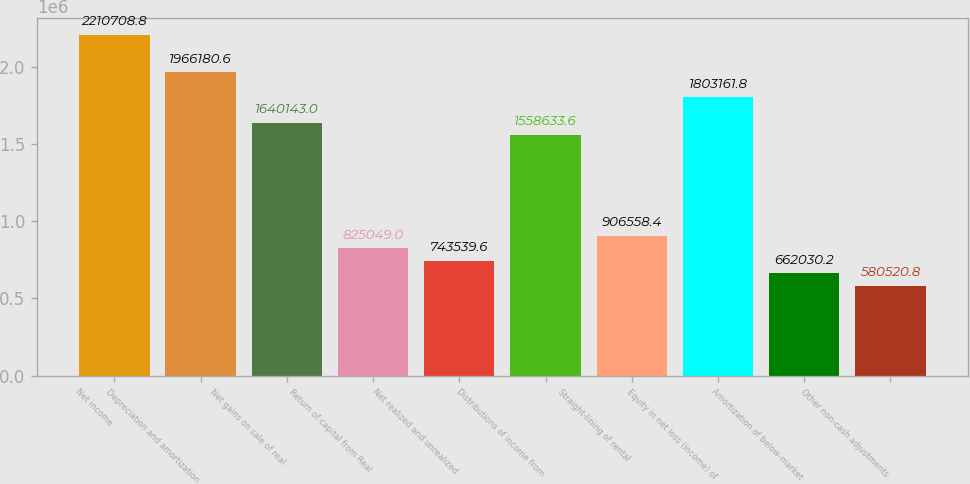<chart> <loc_0><loc_0><loc_500><loc_500><bar_chart><fcel>Net income<fcel>Depreciation and amortization<fcel>Net gains on sale of real<fcel>Return of capital from Real<fcel>Net realized and unrealized<fcel>Distributions of income from<fcel>Straight-lining of rental<fcel>Equity in net loss (income) of<fcel>Amortization of below-market<fcel>Other non-cash adjustments<nl><fcel>2.21071e+06<fcel>1.96618e+06<fcel>1.64014e+06<fcel>825049<fcel>743540<fcel>1.55863e+06<fcel>906558<fcel>1.80316e+06<fcel>662030<fcel>580521<nl></chart> 